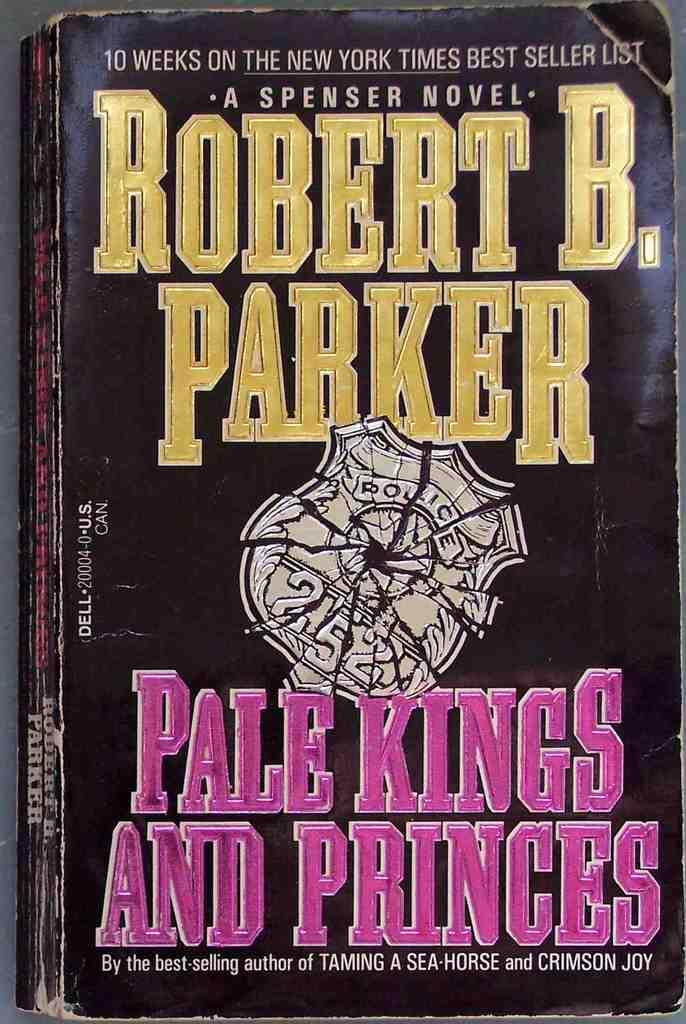<image>
Write a terse but informative summary of the picture. The book Pale Kings and Princes was written by Robert B. Parker. 